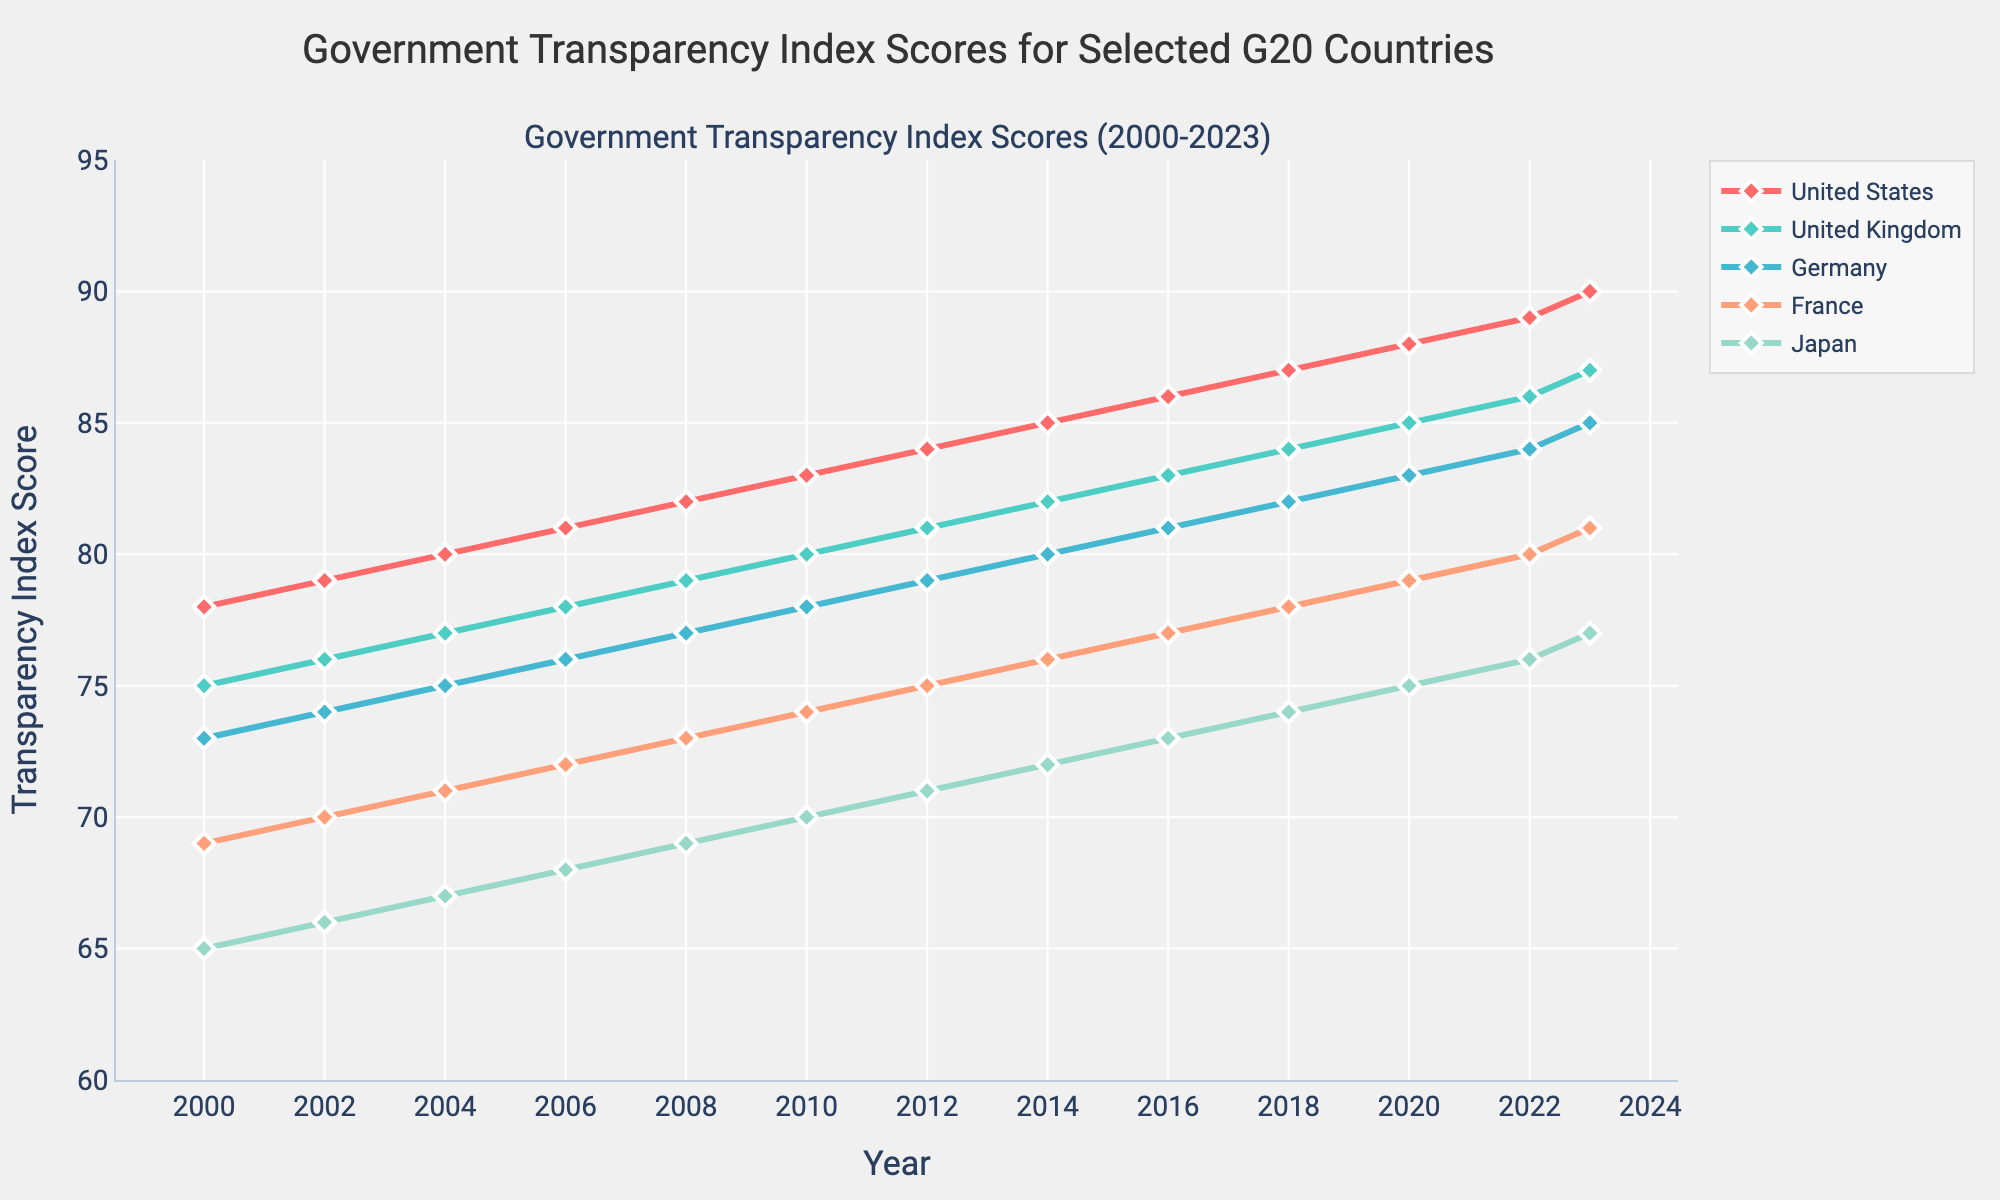What is the general trend in the transparency index score for the United States from 2000 to 2023? From 2000 to 2023, the United States shows a steady increase in transparency index score each year. Starting at 78 in 2000 and reaching 90 in 2023, the trend is consistently upward.
Answer: Steady increase Which country had the highest transparency index score in 2000? Looking at the transparency index scores for 2000, Canada had the highest value at 80.
Answer: Canada How many countries surpassed the score of 80 in the year 2023? In 2023, the countries with scores higher than 80 are the United States (90), United Kingdom (87), Germany (85), France (81), Japan (77), and Canada (92). Thus, 6 countries surpassed the score of 80.
Answer: 6 Did any country's transparency index score decrease over the period of 2000 to 2023? By examining the trends of the listed countries, all of them show an increase in their transparency index scores from 2000 to 2023. There is no decrease.
Answer: No Which country has shown the smallest increase in its transparency index score from 2000 to 2023? Comparing the increase, Japan shows the smallest increment. Its score increased from 65 in 2000 to 77 in 2023, making it an increment of 12.
Answer: Japan Between 2010 and 2015, which country had the most substantial increase in its transparency index score? From the figure, the United Kingdom increased from 80 in 2010 to 86 in 2015. This is the largest change among the listed countries in that period.
Answer: United Kingdom How do the transparency index scores of Germany and France compare in 2004? In the year 2004, Germany had a transparency index score of 75, while France had a score of 71. Thus, Germany's score was higher than France's.
Answer: Germany's score was higher What is the average transparency index score of France from 2000 to 2023? To find the average, add up all the annual scores for France and divide by the number of years. The total is 69+70+71+72+73+74+75+76+77+78+79+80+81 = 925 over 13 years. The average is 925/13 = 71.15.
Answer: 71.15 What color represents Canada in the figure? The figure uses different colors for each country. Canada is represented by a green line.
Answer: Green Which country exhibited the highest overall transparency index score increase from 2000 to 2023? To determine the highest increase, compare the scores. Canada increased from 80 in 2000 to 92 in 2023, which is an increase of 12. For the other countries: 
United States (12), United Kingdom (12), Germany (12), France (12), Japan (12). Therefore, the top scorer is Canada with an increase of 12.
Answer: Canada 